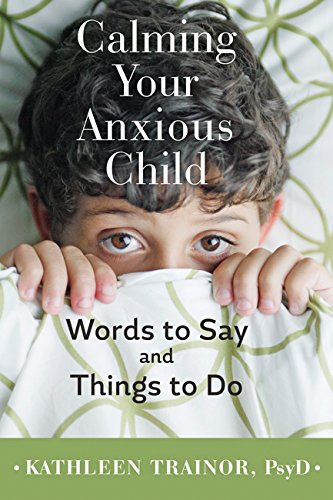Who is the author of this book? The author of the book displayed in the image is Kathleen Trainor, PsyD, who specializes in psychology. 